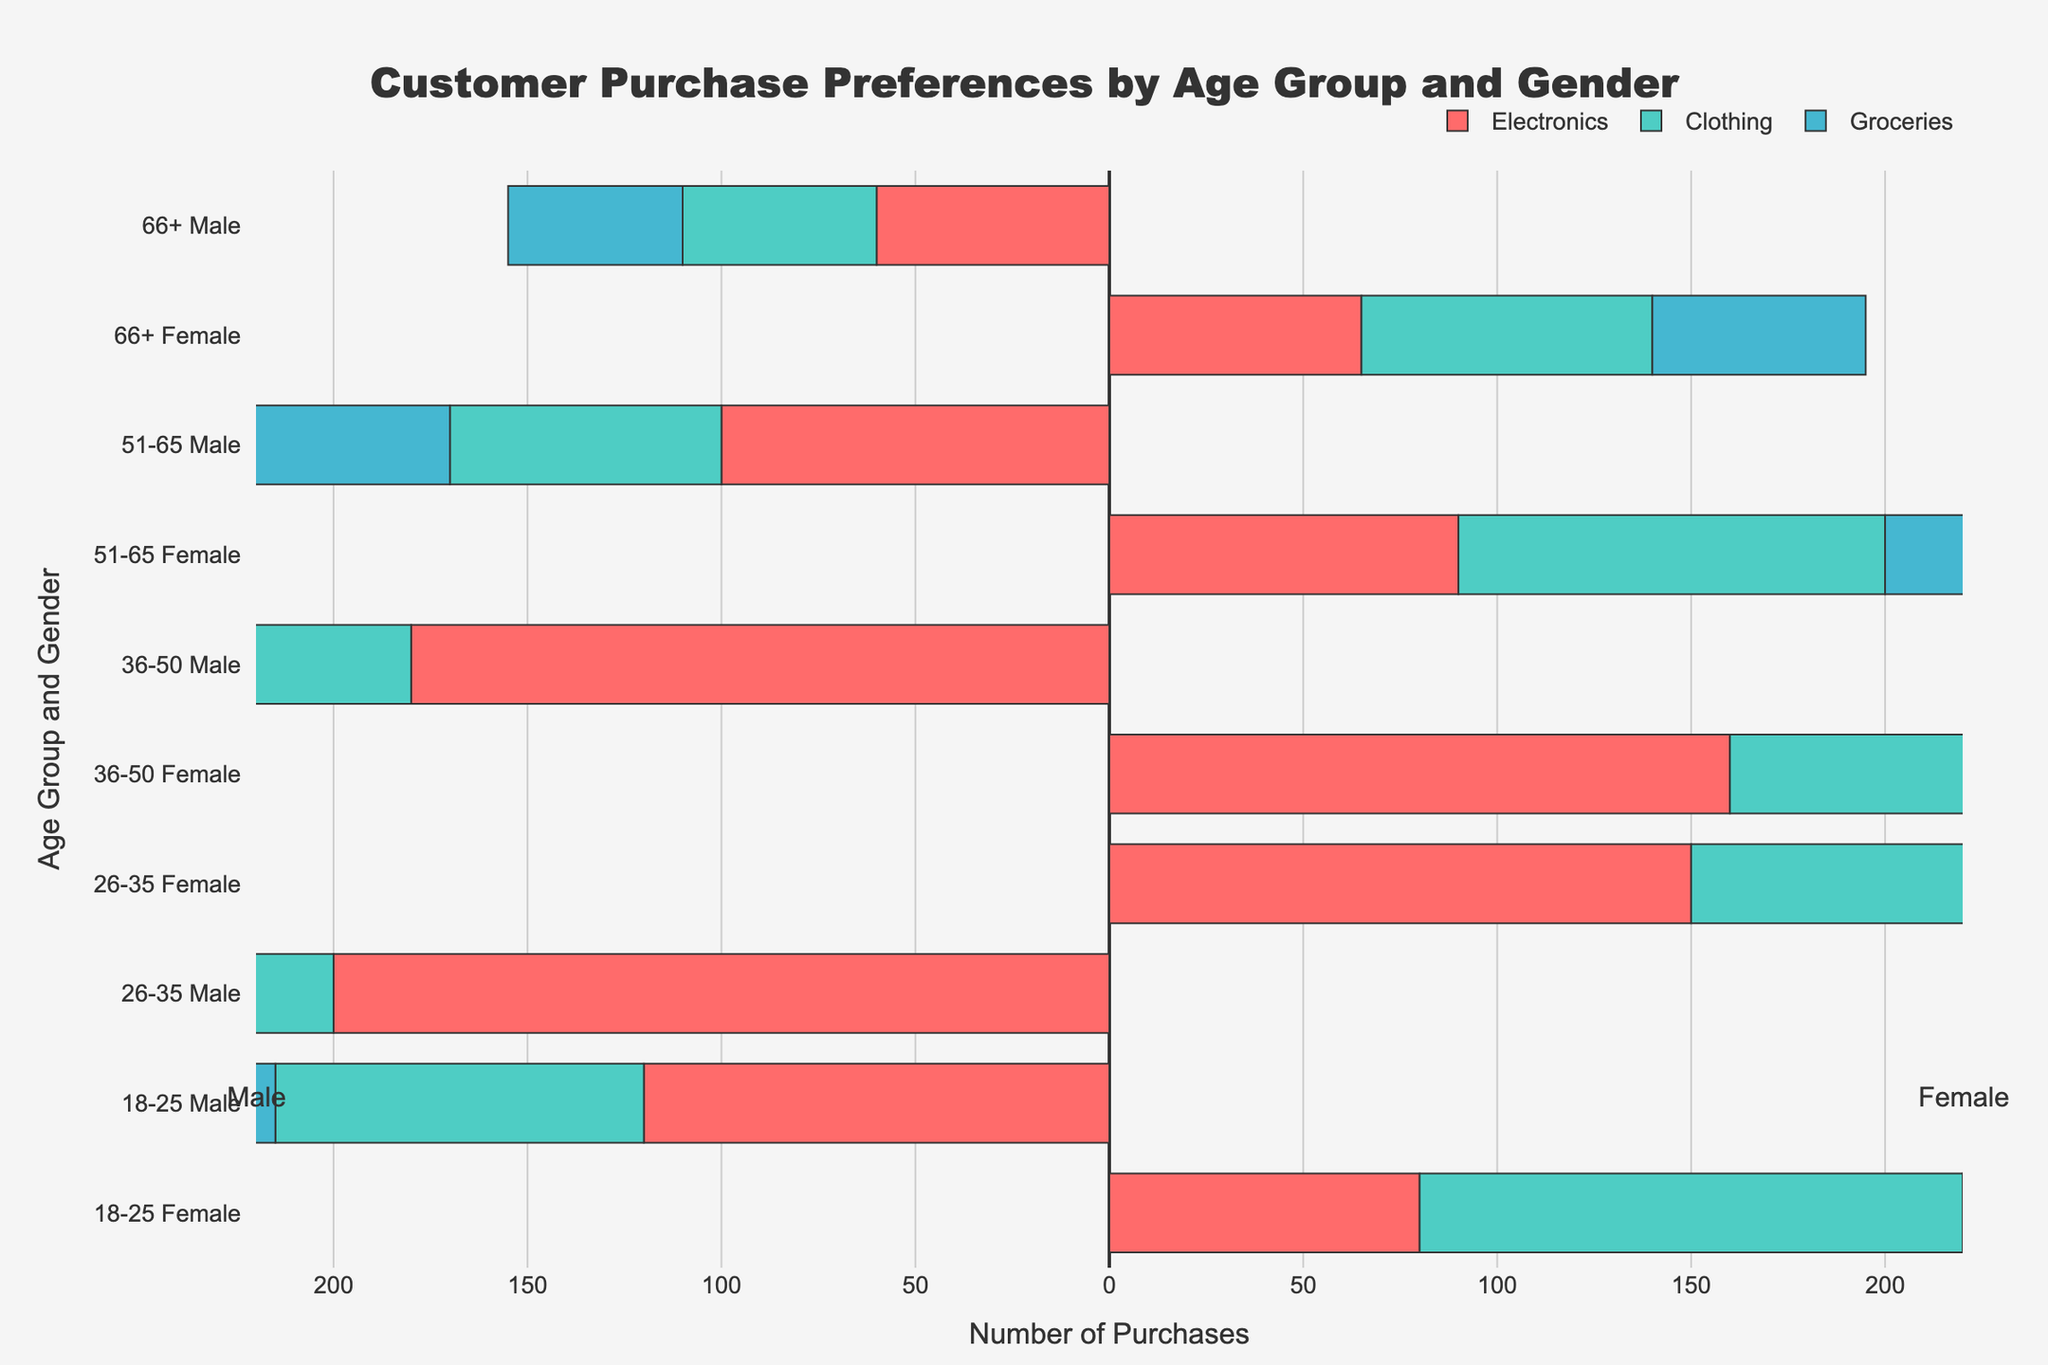What's the most purchased product category among 18-25-year-old females? Observe the lengths of the bars for the 18-25 female group. The bar for Clothing is the longest.
Answer: Clothing Which gender and age group had the highest number of purchases in Electronics? Compare the lengths of the bars in the Electronics category across all age groups and genders. The longest bar is for males aged 26-35.
Answer: 26-35 males What's the total number of purchases for Groceries among 26-35-year-old individuals? Sum the lengths of the Groceries bars for both males and females aged 26-35. Males: 110, Females: 100. Total: 110 + 100 = 210.
Answer: 210 Compare the purchases in Clothing between 36-50 males and females. Which group had more purchases and by how much? Look at the lengths of the Clothing bars for 36-50 males and females. Females: 160, Males: 90. Difference: 160 - 90 = 70.
Answer: Females by 70 Is the number of Clothing purchases by 18-25-year-old females greater than the number of Electronics purchases by 26-35-year-old females? Check the lengths of the respective bars. Clothing for 18-25 females: 140. Electronics for 26-35 females: 150. 140 is less than 150.
Answer: No What's the average number of Electronics purchases across all age groups for males? Sum the lengths of the Electronics bars for all male age groups and then divide by the number of age groups. 120 + 200 + 180 + 100 + 60 = 660. There are 5 age groups. Average: 660 / 5 = 132.
Answer: 132 Is the total number of purchases for Groceries greater for 51-65 females or 66+ males? Check the lengths of the Groceries bars for 51-65 females and 66+ males. 51-65 females: 95. 66+ males: 45. 95 is greater than 45.
Answer: 51-65 females How many more purchases were made by 36-50-year-old individuals in Groceries compared to Electronics? Sum the Groceries and Electronics purchases for both genders aged 36-50. Groceries: 130 (males) + 140 (females) = 270, Electronics: 180 (males) + 160 (females) = 340. Difference: 340 - 270 = 70.
Answer: 70 more for Electronics 